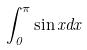<formula> <loc_0><loc_0><loc_500><loc_500>\int _ { 0 } ^ { \pi } \sin x d x</formula> 